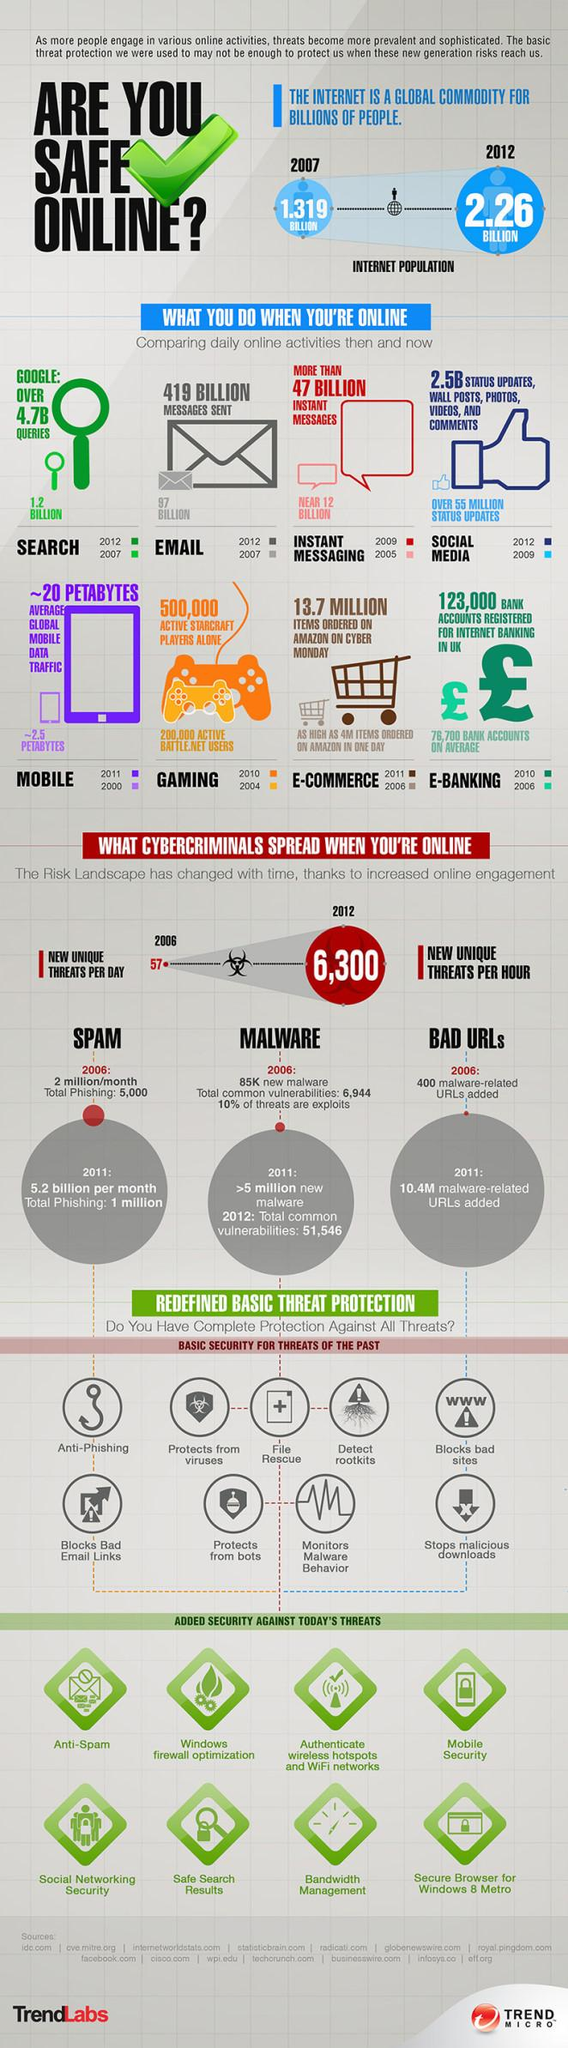Indicate a few pertinent items in this graphic. From 2007 to 2012, the internet population increased by 0.941 billion people. 